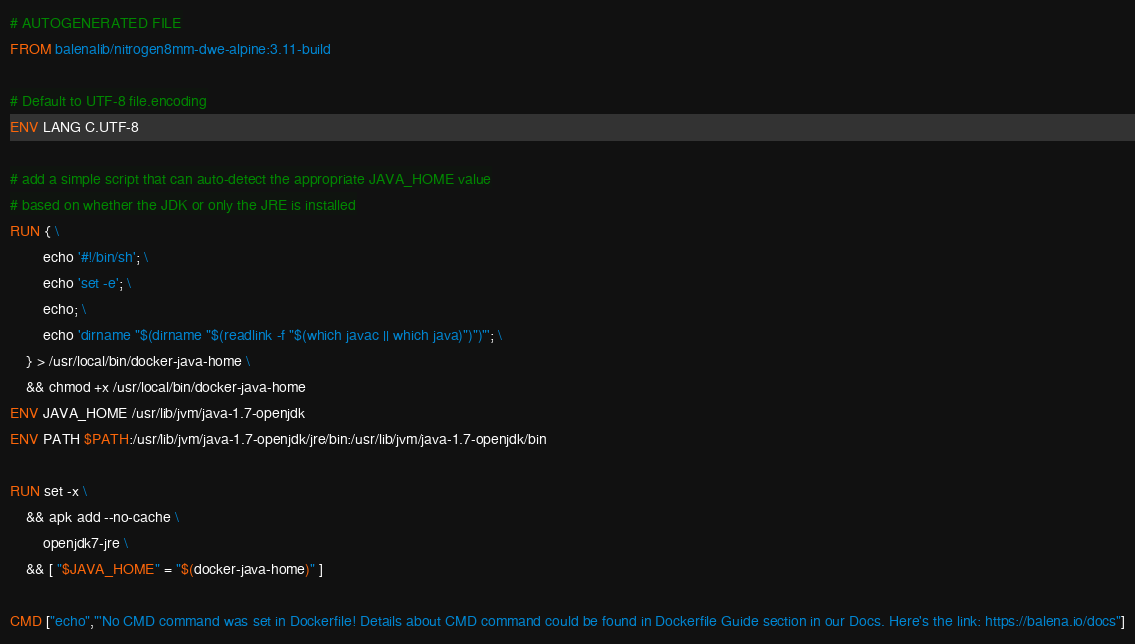<code> <loc_0><loc_0><loc_500><loc_500><_Dockerfile_># AUTOGENERATED FILE
FROM balenalib/nitrogen8mm-dwe-alpine:3.11-build

# Default to UTF-8 file.encoding
ENV LANG C.UTF-8

# add a simple script that can auto-detect the appropriate JAVA_HOME value
# based on whether the JDK or only the JRE is installed
RUN { \
		echo '#!/bin/sh'; \
		echo 'set -e'; \
		echo; \
		echo 'dirname "$(dirname "$(readlink -f "$(which javac || which java)")")"'; \
	} > /usr/local/bin/docker-java-home \
	&& chmod +x /usr/local/bin/docker-java-home
ENV JAVA_HOME /usr/lib/jvm/java-1.7-openjdk
ENV PATH $PATH:/usr/lib/jvm/java-1.7-openjdk/jre/bin:/usr/lib/jvm/java-1.7-openjdk/bin

RUN set -x \
	&& apk add --no-cache \
		openjdk7-jre \
	&& [ "$JAVA_HOME" = "$(docker-java-home)" ]

CMD ["echo","'No CMD command was set in Dockerfile! Details about CMD command could be found in Dockerfile Guide section in our Docs. Here's the link: https://balena.io/docs"]
</code> 